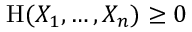Convert formula to latex. <formula><loc_0><loc_0><loc_500><loc_500>H ( X _ { 1 } , \dots , X _ { n } ) \geq 0</formula> 